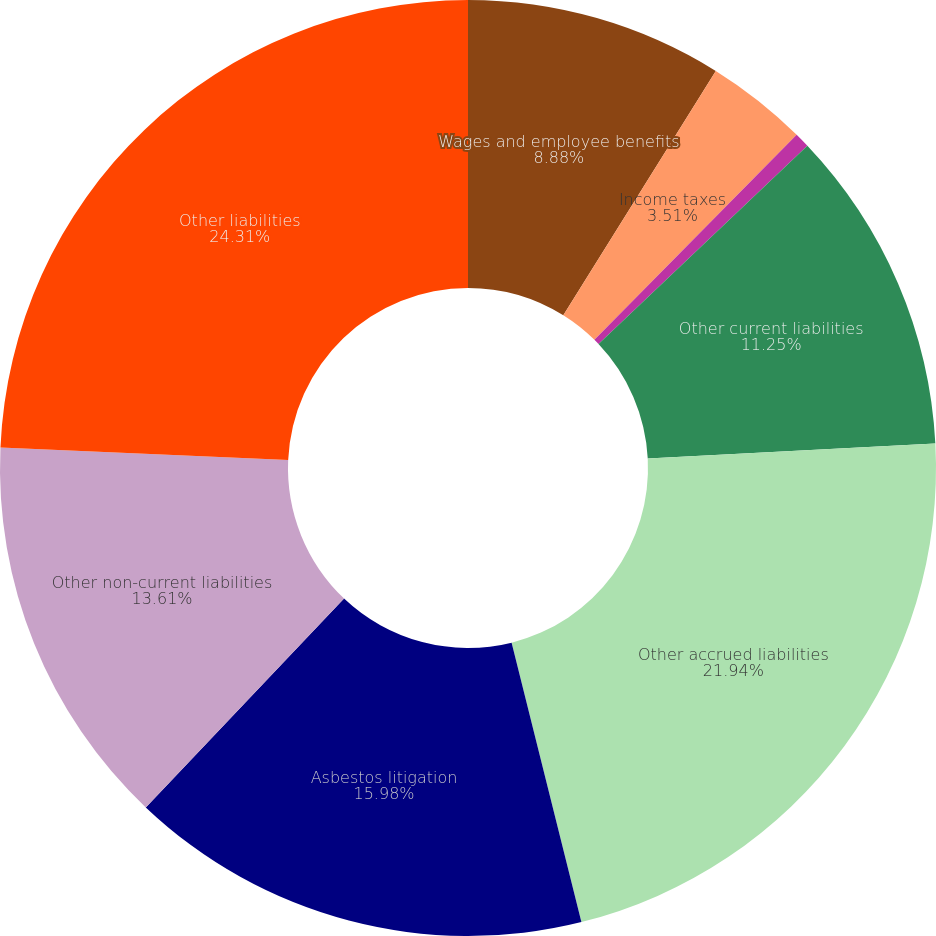Convert chart to OTSL. <chart><loc_0><loc_0><loc_500><loc_500><pie_chart><fcel>Wages and employee benefits<fcel>Income taxes<fcel>Customer deposits<fcel>Other current liabilities<fcel>Other accrued liabilities<fcel>Asbestos litigation<fcel>Other non-current liabilities<fcel>Other liabilities<nl><fcel>8.88%<fcel>3.51%<fcel>0.52%<fcel>11.25%<fcel>21.94%<fcel>15.98%<fcel>13.61%<fcel>24.3%<nl></chart> 